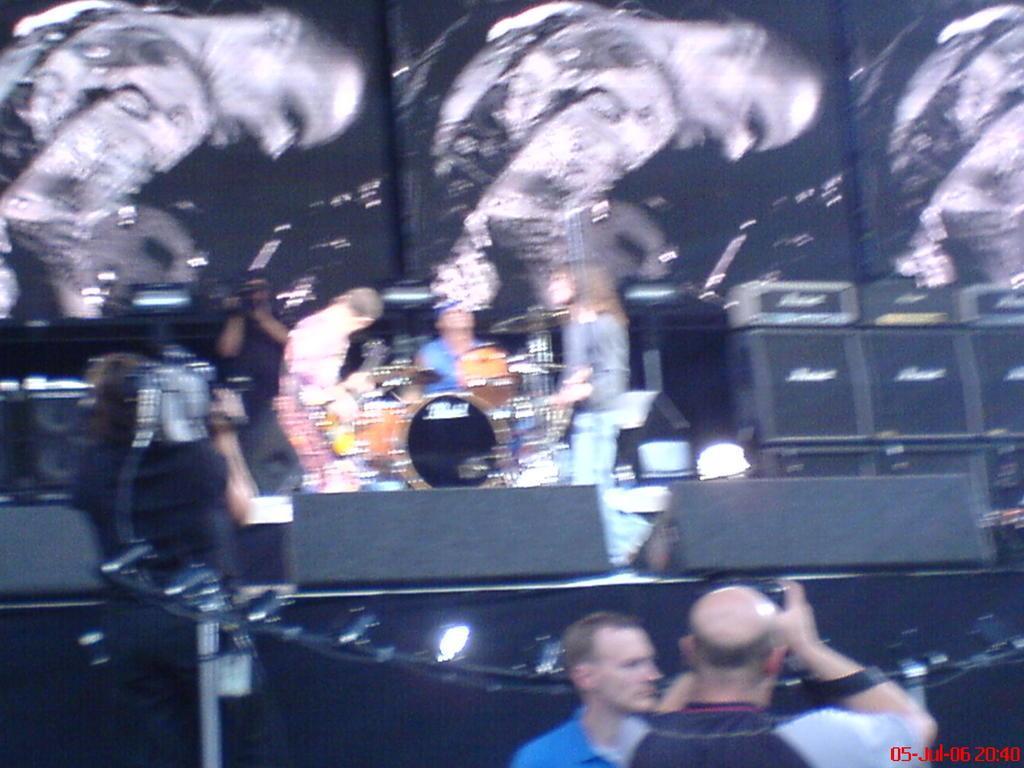Please provide a concise description of this image. This image looks like it is clicked in a concert. The image is blurred. At the bottom, there are two men standing. The man holding the camera is capturing the image. In the background, there are pictures. To the right, there are speakers. At the bottom, there is a black curtain. 